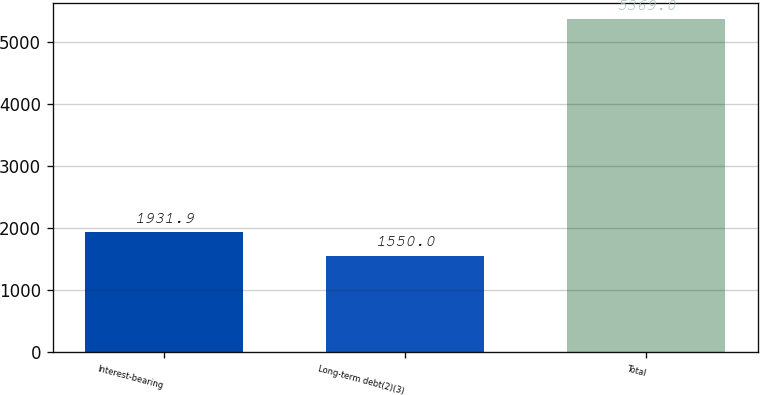Convert chart to OTSL. <chart><loc_0><loc_0><loc_500><loc_500><bar_chart><fcel>Interest-bearing<fcel>Long-term debt(2)(3)<fcel>Total<nl><fcel>1931.9<fcel>1550<fcel>5369<nl></chart> 